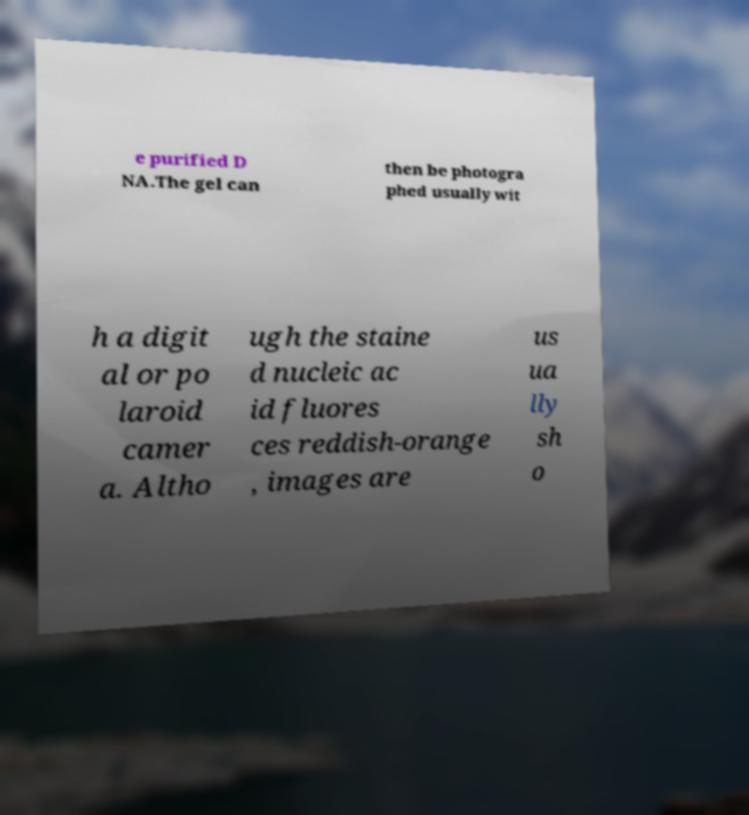What messages or text are displayed in this image? I need them in a readable, typed format. e purified D NA.The gel can then be photogra phed usually wit h a digit al or po laroid camer a. Altho ugh the staine d nucleic ac id fluores ces reddish-orange , images are us ua lly sh o 